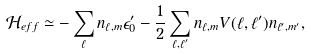Convert formula to latex. <formula><loc_0><loc_0><loc_500><loc_500>\mathcal { H } _ { e f f } \simeq - \sum _ { \ell } n _ { \ell , m } \epsilon _ { 0 } ^ { \prime } - \frac { 1 } { 2 } \sum _ { \ell , \ell ^ { \prime } } n _ { \ell , m } V ( \ell , \ell ^ { \prime } ) n _ { \ell ^ { \prime } , m ^ { \prime } } ,</formula> 